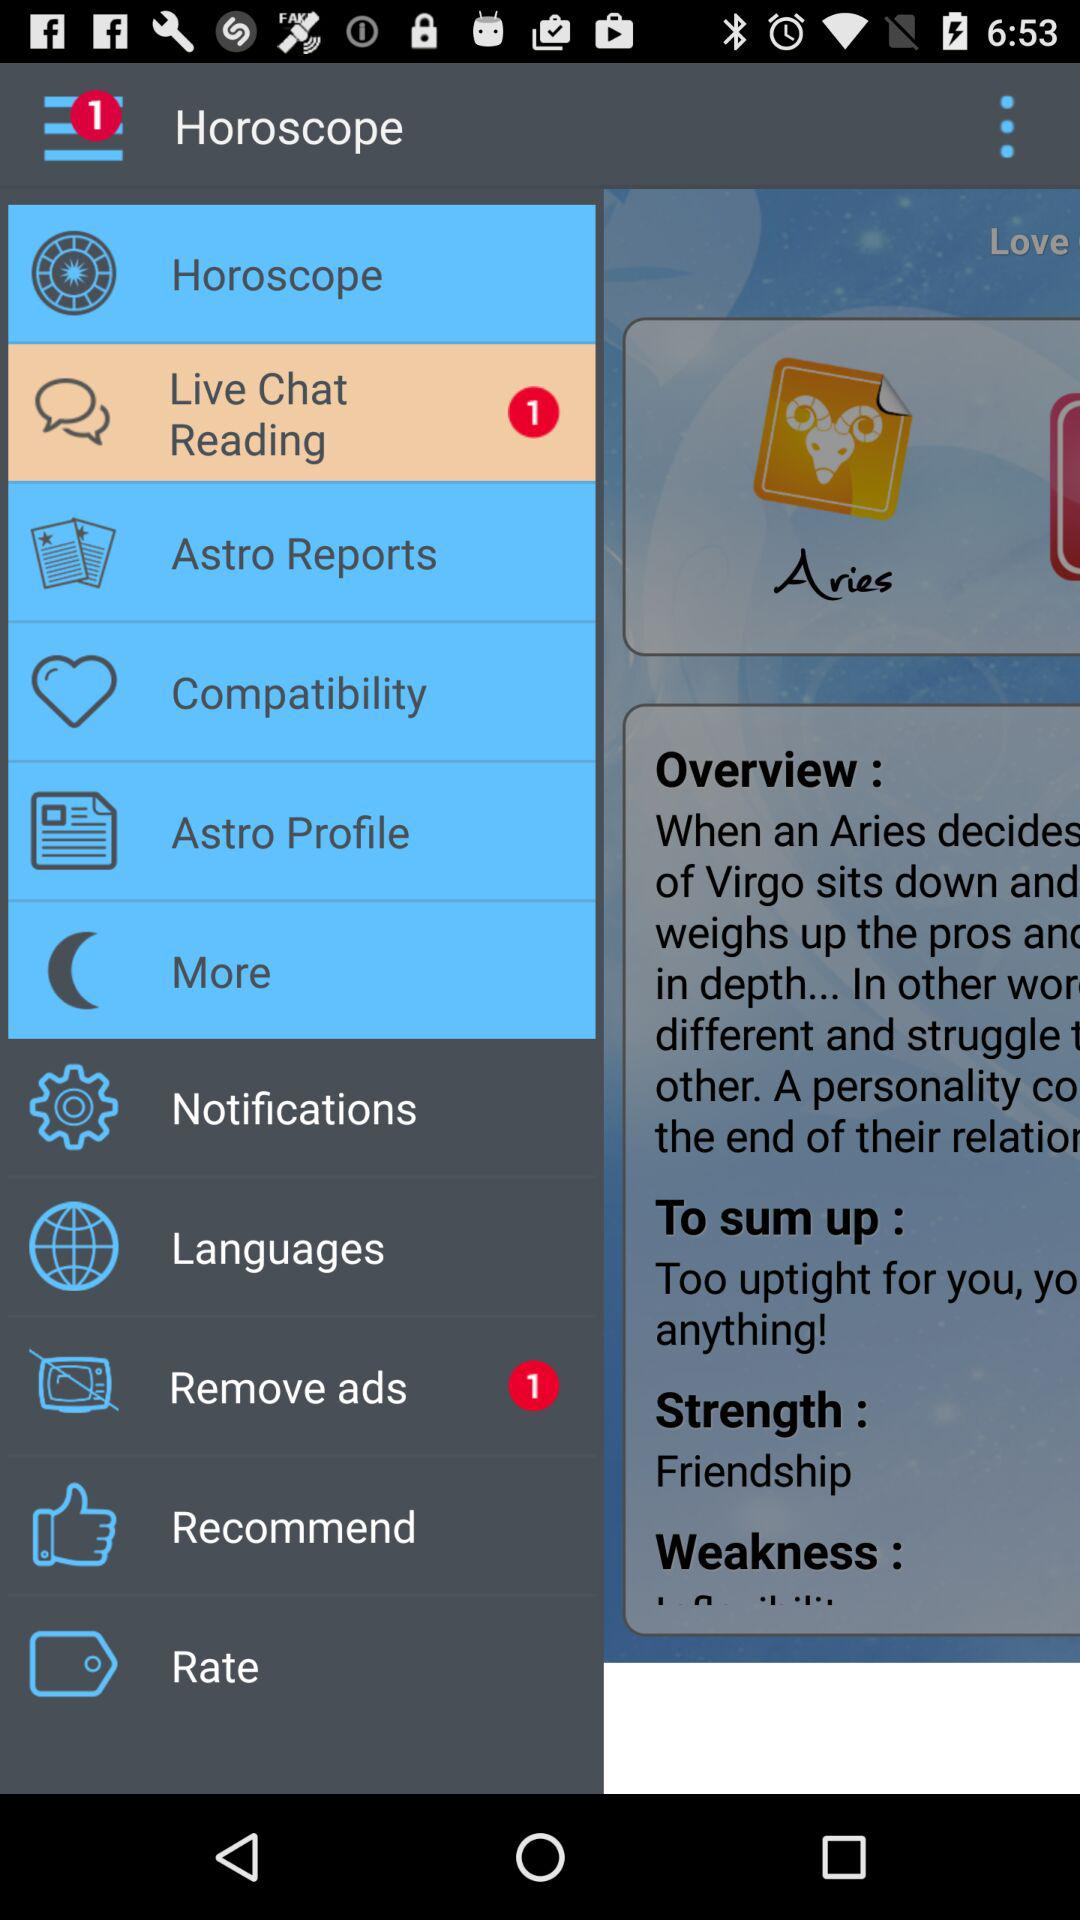Which item is selected? The selected item is "Live Chat Reading". 